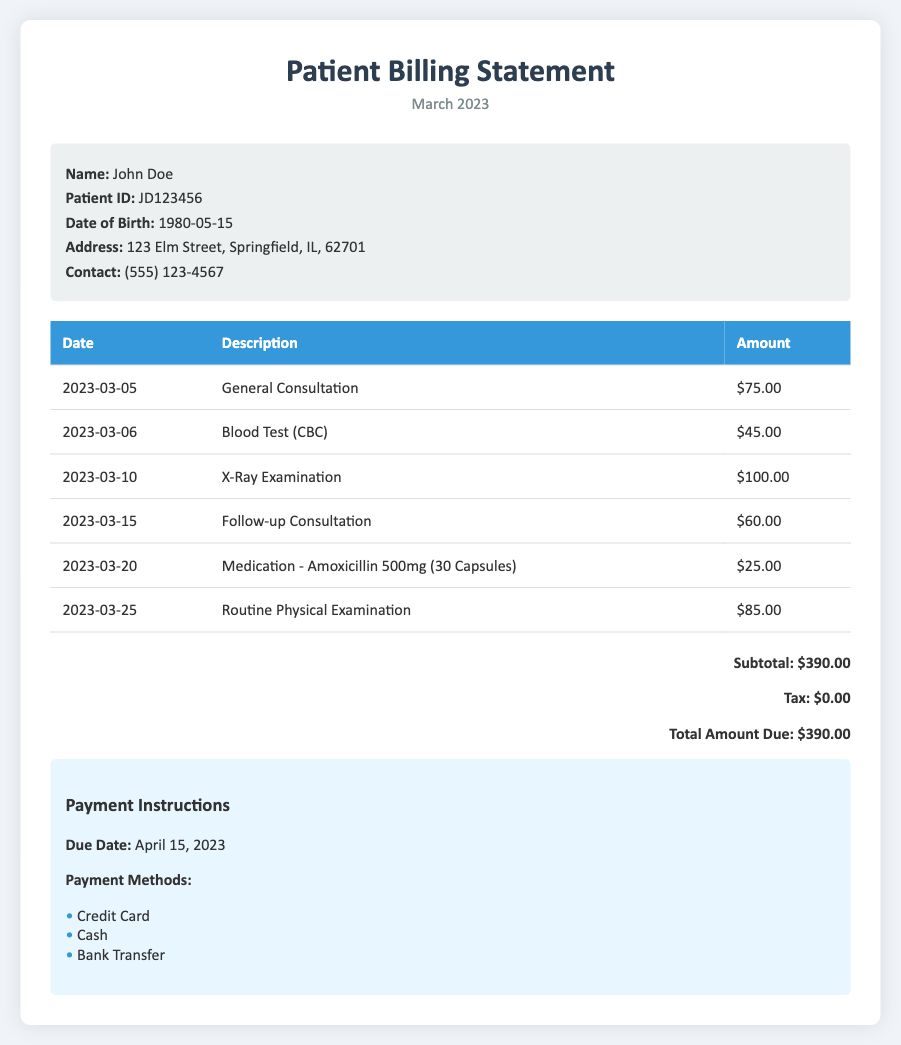What is the patient's name? The patient's name is listed in the patient information section of the document.
Answer: John Doe What is the total amount due? The total amount due is calculated at the bottom of the charges table.
Answer: $390.00 How many capsules of Amoxicillin were provided? The document mentions the quantity of Amoxicillin in the description of the medication charge.
Answer: 30 Capsules What was the date of the X-Ray Examination? The date of the X-Ray Examination can be found in the itemized list of services provided.
Answer: 2023-03-10 What is the due date for payment? The due date is listed in the payment instructions section of the document.
Answer: April 15, 2023 What was the amount charged for the Blood Test? The amount charged for the Blood Test can be found in the itemized list.
Answer: $45.00 How many consultations were billed in total? To find the total consultations, count the number of consultation entries in the itemized list.
Answer: 2 Consultations What is the tax amount on the total charges? The tax amount is explicitly mentioned in the document.
Answer: $0.00 What is the payment method that is NOT listed? The document lists specific payment methods; identifying one not mentioned qualifies as reasoning.
Answer: Check 